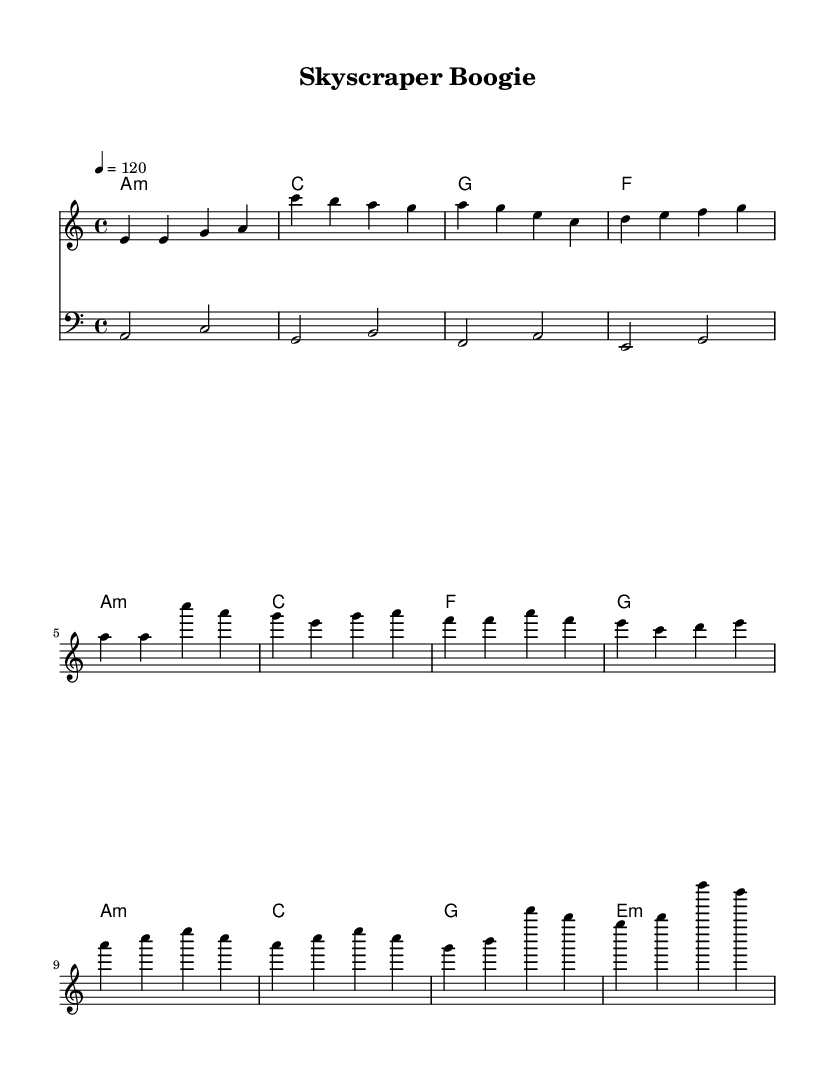What is the key signature of this music? The key signature is A minor, which has no sharps or flats.
Answer: A minor What is the time signature of this music? The time signature displayed is 4/4, indicating four beats per measure.
Answer: 4/4 What is the tempo marking of this music? The tempo marking indicates a speed of 120 beats per minute, suggesting a lively pace.
Answer: 120 How many measures are in the chorus section? The chorus section consists of four measures, based on the layout of the notes in that section.
Answer: 4 What chords are used in the introduction? The chords in the introduction are A minor, C major, G major, and F major, as displayed in the harmonies section.
Answer: A minor, C, G, F What is the general style of this piece of music? The piece is categorized as Disco, characterized by its upbeat tempo and repetitive structure, often emphasizing dance rhythms.
Answer: Disco What is the rhythmic feel of the bassline in this piece? The bassline maintains a steady rhythm that complements the upbeat nature of Disco music, typically using quarter notes in a 4/4 time signature.
Answer: Steady 